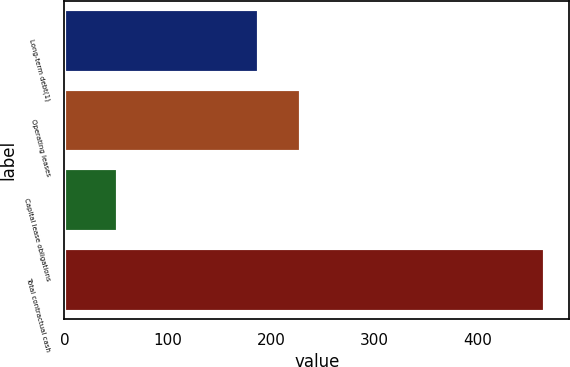Convert chart. <chart><loc_0><loc_0><loc_500><loc_500><bar_chart><fcel>Long-term debt(1)<fcel>Operating leases<fcel>Capital lease obligations<fcel>Total contractual cash<nl><fcel>188<fcel>229.3<fcel>52<fcel>465<nl></chart> 